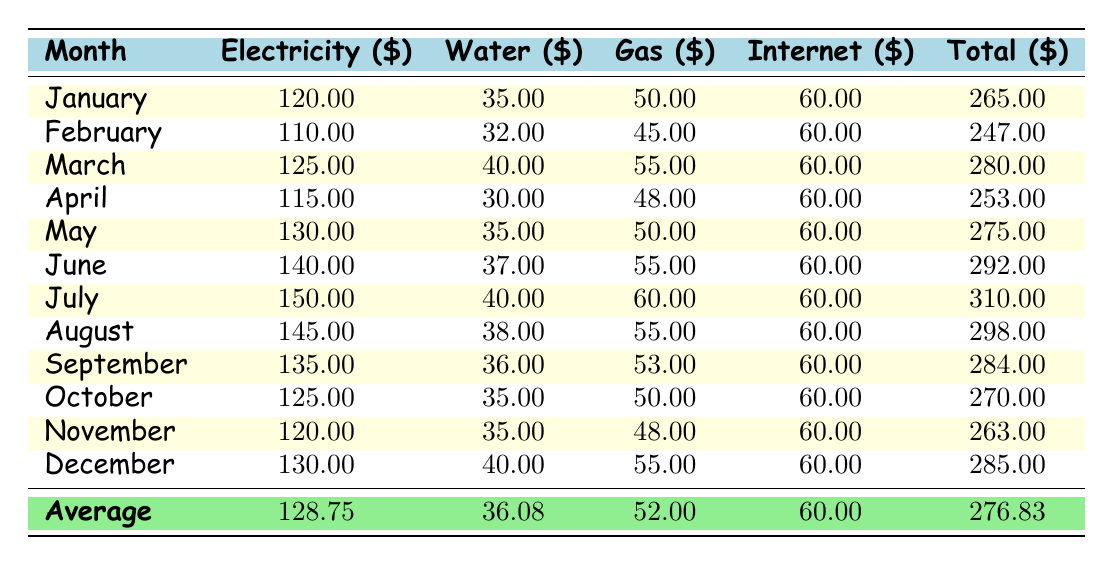What is the total amount spent on electricity in July? The table lists the electricity payment for July as 150.00.
Answer: 150.00 What was the average total utility payment for the year? To find the average total payment, sum all the total payments from each month: (265.00 + 247.00 + 280.00 + 253.00 + 275.00 + 292.00 + 310.00 + 298.00 + 284.00 + 270.00 + 263.00 + 285.00) = 3,201.00. Then divide by the number of months (12): 3,201.00 / 12 = 276.83.
Answer: 276.83 Is the water payment in November higher than the water payment in April? The water payment in November is 35.00, while in April it is 30.00. Since 35.00 is greater than 30.00, the statement is true.
Answer: Yes What is the difference between the highest and lowest internet payment? The highest internet payment is 60.00, which occurs every month, and the lowest internet payment is also 60.00. The difference: 60.00 - 60.00 = 0.
Answer: 0 What was the total utility cost for the month with the highest total payment? The highest total payment is 310.00 in July. Thus, the total utility cost for July is 310.00.
Answer: 310.00 On average, how much was paid for gas monthly? First, add all the gas payments: (50.00 + 45.00 + 55.00 + 48.00 + 50.00 + 55.00 + 60.00 + 55.00 + 53.00 + 50.00 + 48.00 + 55.00) = 600.00. Then divide by 12 months: 600.00 / 12 = 50.00.
Answer: 50.00 Was the total utility payment in October lower than the payment in February? The total payment in October is 270.00 and in February is 247.00. Since 270.00 is greater than 247.00, the statement is false.
Answer: No Which month had the lowest total utility payment, and what was that amount? February had the lowest total payment of 247.00.
Answer: February, 247.00 